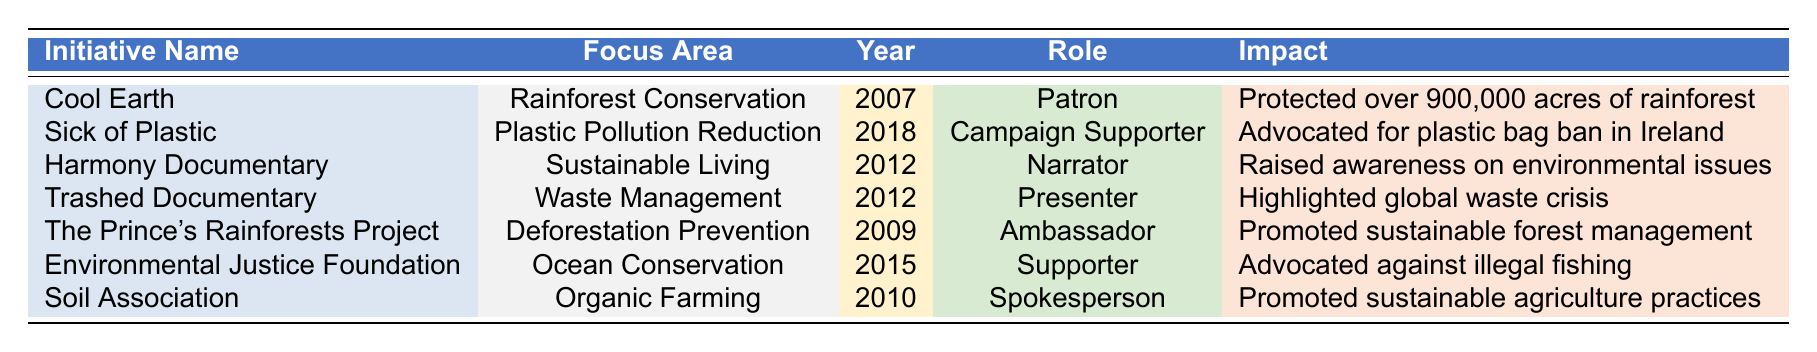What is the focus area of the initiative "Cool Earth"? The table lists "Cool Earth" under the "Focus Area" column, showing that its focus area is "Rainforest Conservation."
Answer: Rainforest Conservation In what year did Jeremy Irons become involved with the "Sick of Plastic" initiative? By looking at the "Year Involved" column next to "Sick of Plastic," we see that Jeremy Irons became involved in the year 2018.
Answer: 2018 What role did Jeremy Irons have in the "Harmony Documentary"? The table indicates that Jeremy Irons was the "Narrator" for the "Harmony Documentary."
Answer: Narrator How many initiatives focused on waste management? Referring to the "Focus Area" column, we find "Waste Management" listed only once for the "Trashed Documentary." Thus, there is only one initiative focusing on this area.
Answer: 1 Did Jeremy Irons advocate against illegal fishing through the Environmental Justice Foundation? The "Impact" column for the Environmental Justice Foundation states that he "Advocated against illegal fishing," confirming that he did.
Answer: Yes What is the combined number of years involved for the initiatives related to plastic pollution reduction and organic farming? The years involved for the "Sick of Plastic" initiative is 2018 and for the "Soil Association" is 2010. Calculating the difference: 2018 - 2010 = 8 years. Therefore, the combined number is not relevant here, but if we focus purely on the years involved separately, we have two valid entries focused on addressing pollution and farming.
Answer: 8 years What initiative was involved with ocean conservation in 2015? The table specifies that in 2015, the initiative focused on ocean conservation is the "Environmental Justice Foundation."
Answer: Environmental Justice Foundation How many roles did Jeremy Irons take on across the initiatives listed? By counting the distinct roles listed in the "Role" column for each initiative, we find six roles: Patron, Campaign Supporter, Narrator, Presenter, Ambassador, and Supporter. Hence, he has taken on a variety of roles.
Answer: 6 Which two initiatives did Jeremy Irons support in 2012? The table shows that in 2012, Jeremy Irons was involved with two initiatives: "Harmony Documentary" and "Trashed Documentary."
Answer: Harmony Documentary and Trashed Documentary In how many initiatives is Jeremy Irons listed as a supporter or spokesperson? Reviewing the roles, "Supporter" appears once for the "Environmental Justice Foundation," and "Spokesperson" appears once for the "Soil Association." Therefore, he participated in a total of two initiatives with these roles.
Answer: 2 Which initiative had the greatest impact in terms of area protected? "Cool Earth" is listed with the impact of protecting over 900,000 acres of rainforest, which is significantly larger than the impacts of the other initiatives, indicating it had the greatest impact.
Answer: Cool Earth 